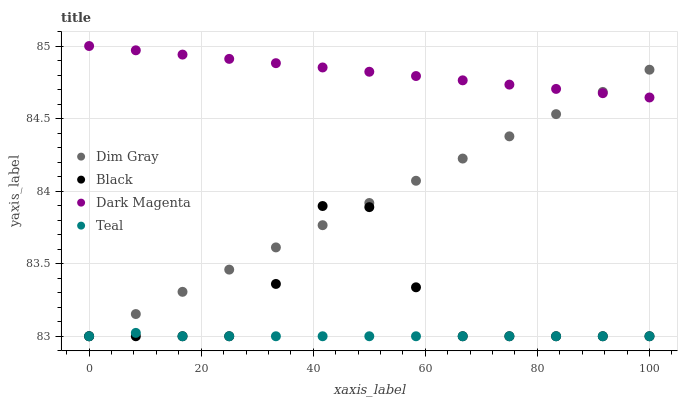Does Teal have the minimum area under the curve?
Answer yes or no. Yes. Does Dark Magenta have the maximum area under the curve?
Answer yes or no. Yes. Does Black have the minimum area under the curve?
Answer yes or no. No. Does Black have the maximum area under the curve?
Answer yes or no. No. Is Dim Gray the smoothest?
Answer yes or no. Yes. Is Black the roughest?
Answer yes or no. Yes. Is Dark Magenta the smoothest?
Answer yes or no. No. Is Dark Magenta the roughest?
Answer yes or no. No. Does Dim Gray have the lowest value?
Answer yes or no. Yes. Does Dark Magenta have the lowest value?
Answer yes or no. No. Does Dark Magenta have the highest value?
Answer yes or no. Yes. Does Black have the highest value?
Answer yes or no. No. Is Teal less than Dark Magenta?
Answer yes or no. Yes. Is Dark Magenta greater than Teal?
Answer yes or no. Yes. Does Dim Gray intersect Black?
Answer yes or no. Yes. Is Dim Gray less than Black?
Answer yes or no. No. Is Dim Gray greater than Black?
Answer yes or no. No. Does Teal intersect Dark Magenta?
Answer yes or no. No. 